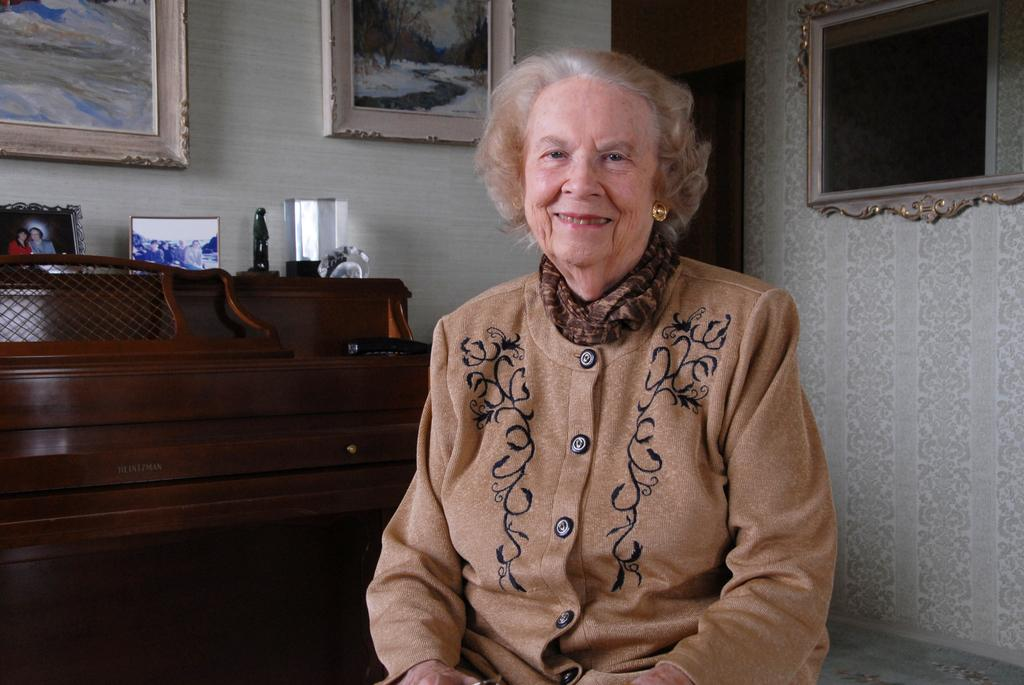What is the woman in the image doing? The woman is sitting and smiling in the image. What can be seen on the wall in the image? There are photo frames on the wall. What can be seen on the table in the image? There are photo frames, a statue, and other objects on the table. How many tomatoes are on the quilt in the image? There are no tomatoes or quilts present in the image. 